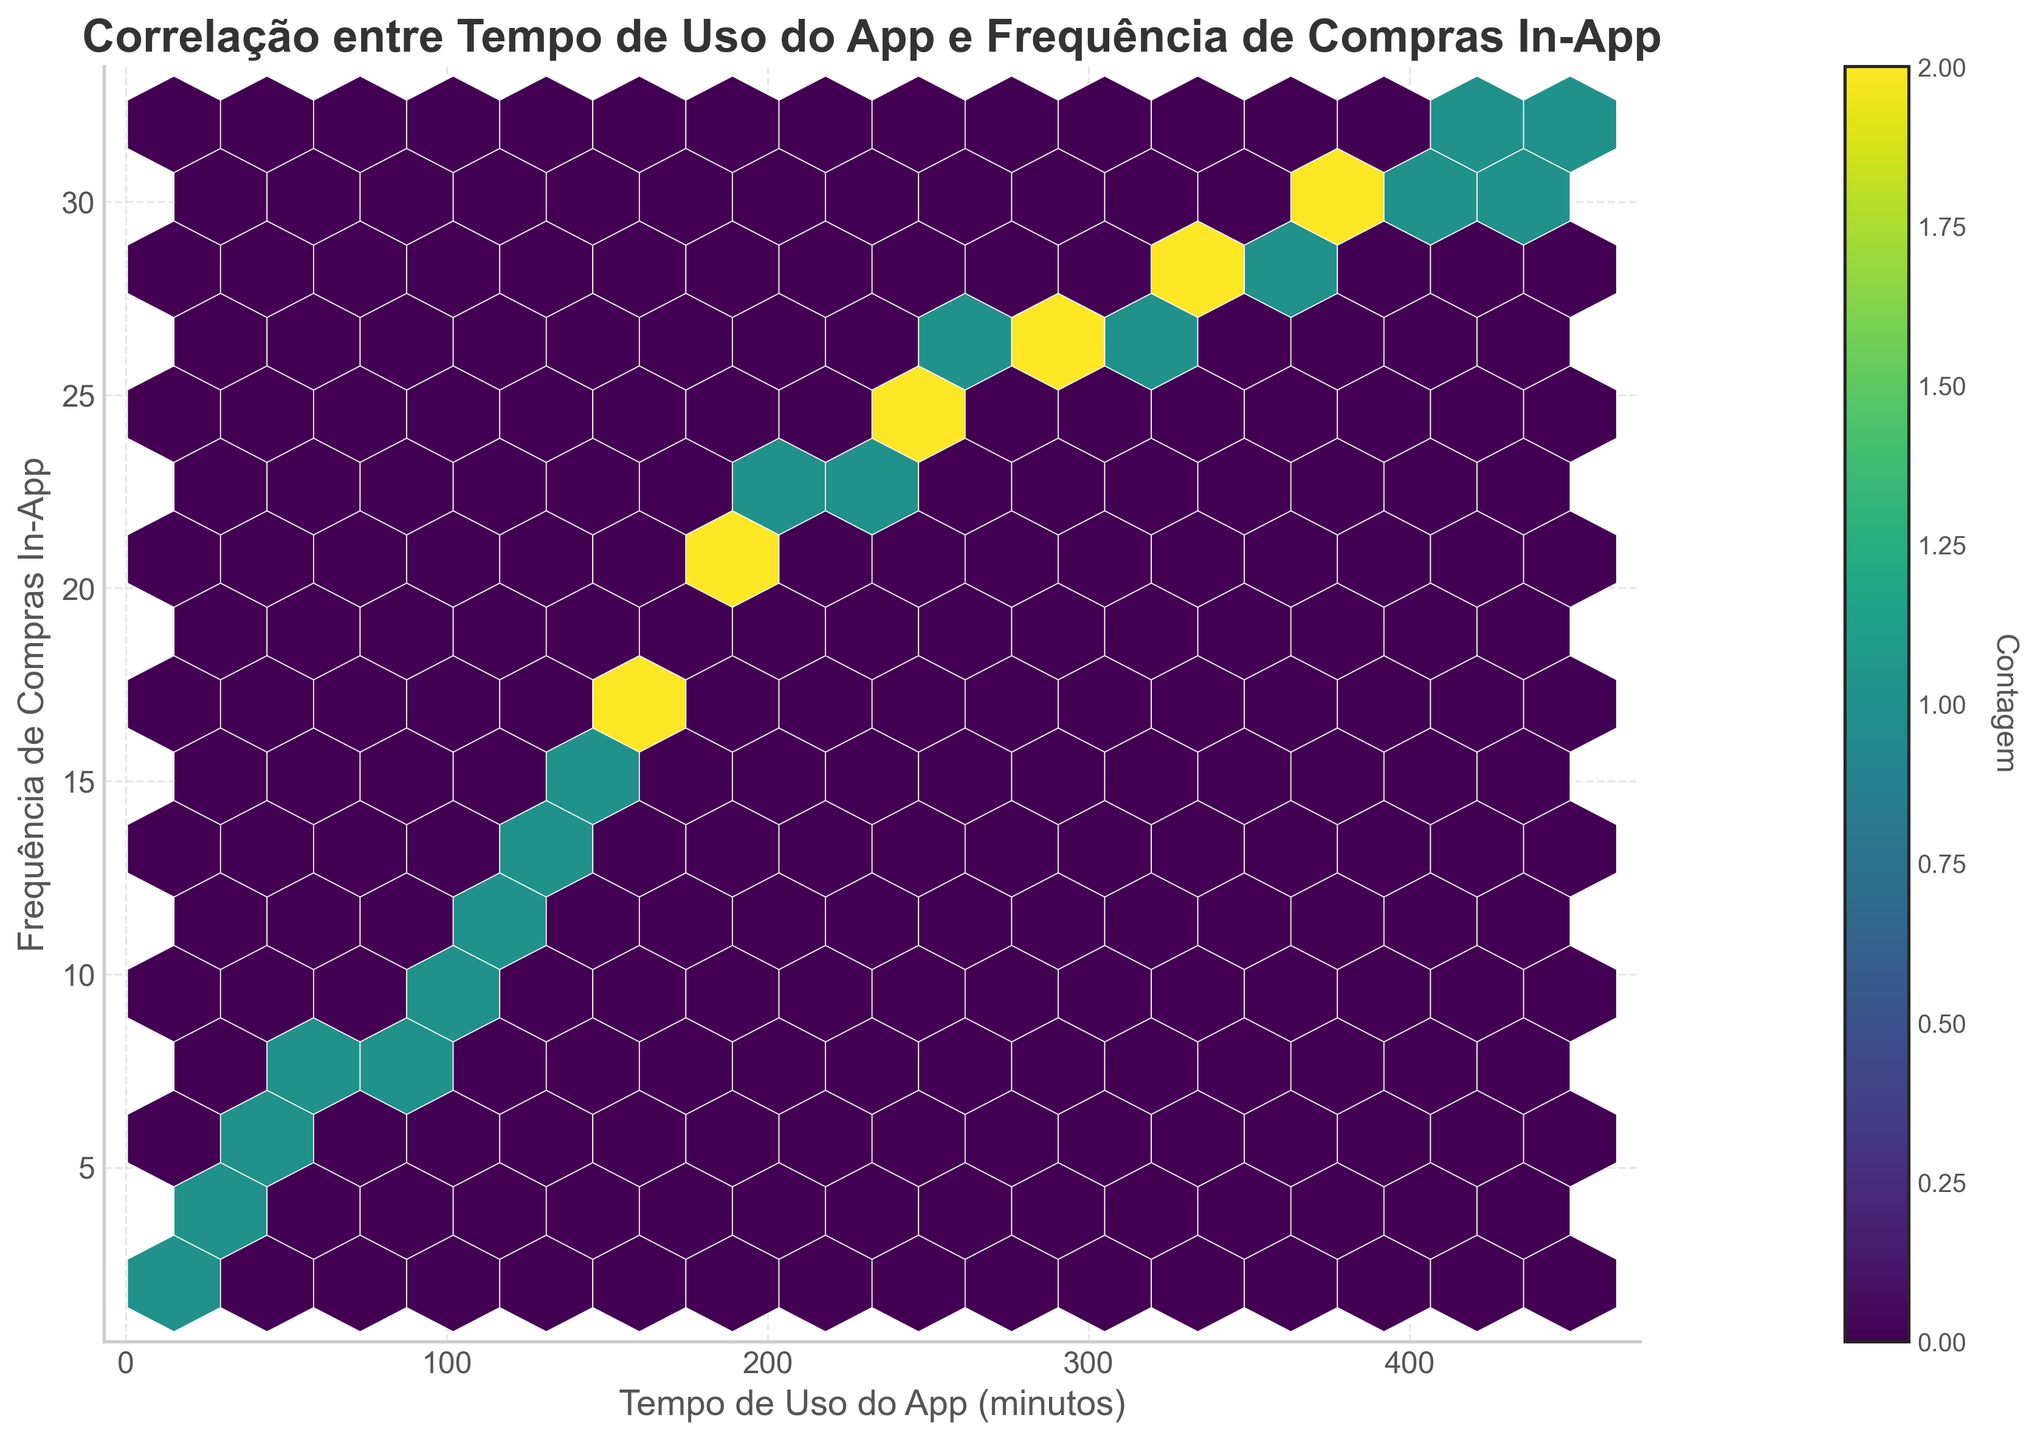What is the title of the plot? The title of the plot is usually stated at the top, and in this case, it reads "Correlação entre Tempo de Uso do App e Frequência de Compras In-App"
Answer: Correlação entre Tempo de Uso do App e Frequência de Compras In-App What do the x-axis and y-axis represent? The label on the x-axis is "Tempo de Uso do App (minutos)" which indicates the app usage time in minutes. The y-axis is labeled "Frequência de Compras In-App," which indicates the frequency of in-app purchases.
Answer: Tempo de Uso do App (minutos) and Frequência de Compras In-App How many hexagons are displayed in the plot? By counting the individual hexagons, it appears that there are multiple hexagons clustered in the plot, with the exact count requiring visual investigation.
Answer: 15 What is the range of app usage time displayed on the x-axis? The x-axis starts from 0 minutes and extends to 450 minutes, as indicated by the axis ticks.
Answer: 0 to 450 minutes Where is the highest density of data points observed in the plot? The highest density of data points is observed in the area where the hexagons have a darker shade of color, which appears to be around an app usage time of 360 to 450 minutes and in-app purchases ranging from 29 to 32.
Answer: Around 360 to 450 minutes and 29 to 32 in-app purchases Does the color bar indicate a higher frequency of points in certain areas of the hexbin plot? Yes, the color bar on the right helps indicate the frequency of points within hexagons. Darker colors represent a higher count of data points within those hexagons.
Answer: Yes Is there a correlation between app usage time and in-app purchase frequency? The spread of points generally shows an upward trend, indicating a positive correlation between app usage time and in-app purchase frequency.
Answer: Yes, positive correlation Which app usage time interval holds the highest number of hexagons with elevated purchase frequency? By observing the plot, it appears that the interval of 360 to 450 minutes has the highest number of hexagons with a darker color indicating elevated purchase frequency.
Answer: 360 to 450 minutes What does the color map 'viridis' used in the plot represent? The 'viridis' color map is a gradient from yellow to blue, used to represent the count within each hexagon, with yellow indicating higher counts and blue indicating lower counts.
Answer: Count within each hexagon 